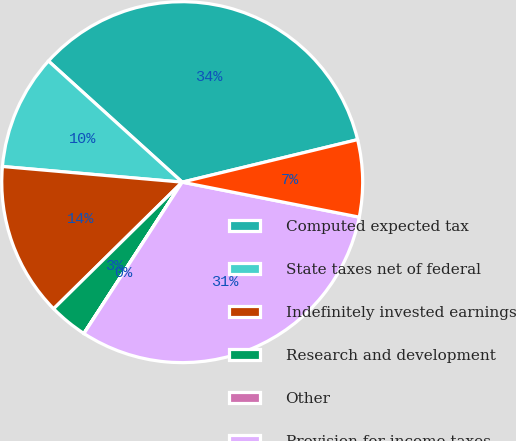Convert chart to OTSL. <chart><loc_0><loc_0><loc_500><loc_500><pie_chart><fcel>Computed expected tax<fcel>State taxes net of federal<fcel>Indefinitely invested earnings<fcel>Research and development<fcel>Other<fcel>Provision for income taxes<fcel>Effective tax rate<nl><fcel>34.5%<fcel>10.33%<fcel>13.76%<fcel>3.45%<fcel>0.01%<fcel>31.06%<fcel>6.89%<nl></chart> 